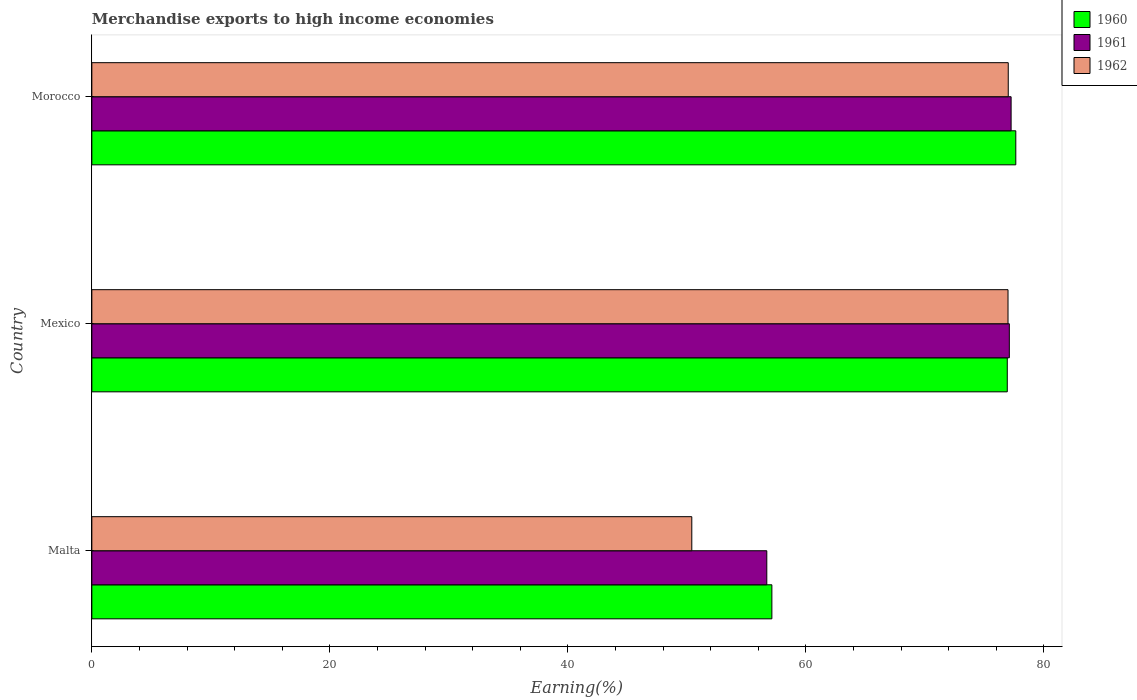How many groups of bars are there?
Ensure brevity in your answer.  3. Are the number of bars per tick equal to the number of legend labels?
Provide a succinct answer. Yes. How many bars are there on the 1st tick from the top?
Make the answer very short. 3. How many bars are there on the 2nd tick from the bottom?
Keep it short and to the point. 3. What is the label of the 1st group of bars from the top?
Ensure brevity in your answer.  Morocco. In how many cases, is the number of bars for a given country not equal to the number of legend labels?
Offer a terse response. 0. What is the percentage of amount earned from merchandise exports in 1960 in Malta?
Keep it short and to the point. 57.14. Across all countries, what is the maximum percentage of amount earned from merchandise exports in 1961?
Your response must be concise. 77.24. Across all countries, what is the minimum percentage of amount earned from merchandise exports in 1960?
Give a very brief answer. 57.14. In which country was the percentage of amount earned from merchandise exports in 1961 maximum?
Provide a short and direct response. Morocco. In which country was the percentage of amount earned from merchandise exports in 1960 minimum?
Keep it short and to the point. Malta. What is the total percentage of amount earned from merchandise exports in 1960 in the graph?
Ensure brevity in your answer.  211.7. What is the difference between the percentage of amount earned from merchandise exports in 1960 in Malta and that in Morocco?
Your answer should be very brief. -20.5. What is the difference between the percentage of amount earned from merchandise exports in 1962 in Morocco and the percentage of amount earned from merchandise exports in 1960 in Malta?
Provide a short and direct response. 19.86. What is the average percentage of amount earned from merchandise exports in 1960 per country?
Keep it short and to the point. 70.57. What is the difference between the percentage of amount earned from merchandise exports in 1962 and percentage of amount earned from merchandise exports in 1960 in Mexico?
Ensure brevity in your answer.  0.06. In how many countries, is the percentage of amount earned from merchandise exports in 1961 greater than 76 %?
Your response must be concise. 2. What is the ratio of the percentage of amount earned from merchandise exports in 1962 in Malta to that in Morocco?
Your answer should be very brief. 0.65. Is the percentage of amount earned from merchandise exports in 1960 in Malta less than that in Morocco?
Your answer should be very brief. Yes. Is the difference between the percentage of amount earned from merchandise exports in 1962 in Malta and Morocco greater than the difference between the percentage of amount earned from merchandise exports in 1960 in Malta and Morocco?
Ensure brevity in your answer.  No. What is the difference between the highest and the second highest percentage of amount earned from merchandise exports in 1961?
Make the answer very short. 0.15. What is the difference between the highest and the lowest percentage of amount earned from merchandise exports in 1960?
Provide a short and direct response. 20.5. What does the 1st bar from the bottom in Malta represents?
Ensure brevity in your answer.  1960. Are all the bars in the graph horizontal?
Ensure brevity in your answer.  Yes. How many countries are there in the graph?
Offer a terse response. 3. Does the graph contain grids?
Give a very brief answer. No. Where does the legend appear in the graph?
Keep it short and to the point. Top right. How are the legend labels stacked?
Keep it short and to the point. Vertical. What is the title of the graph?
Make the answer very short. Merchandise exports to high income economies. What is the label or title of the X-axis?
Offer a very short reply. Earning(%). What is the label or title of the Y-axis?
Provide a succinct answer. Country. What is the Earning(%) in 1960 in Malta?
Ensure brevity in your answer.  57.14. What is the Earning(%) in 1961 in Malta?
Offer a very short reply. 56.72. What is the Earning(%) of 1962 in Malta?
Offer a terse response. 50.41. What is the Earning(%) of 1960 in Mexico?
Offer a terse response. 76.92. What is the Earning(%) in 1961 in Mexico?
Provide a succinct answer. 77.1. What is the Earning(%) of 1962 in Mexico?
Make the answer very short. 76.99. What is the Earning(%) in 1960 in Morocco?
Give a very brief answer. 77.64. What is the Earning(%) of 1961 in Morocco?
Ensure brevity in your answer.  77.24. What is the Earning(%) in 1962 in Morocco?
Offer a very short reply. 77.01. Across all countries, what is the maximum Earning(%) of 1960?
Ensure brevity in your answer.  77.64. Across all countries, what is the maximum Earning(%) of 1961?
Your answer should be compact. 77.24. Across all countries, what is the maximum Earning(%) in 1962?
Offer a terse response. 77.01. Across all countries, what is the minimum Earning(%) of 1960?
Ensure brevity in your answer.  57.14. Across all countries, what is the minimum Earning(%) in 1961?
Your response must be concise. 56.72. Across all countries, what is the minimum Earning(%) in 1962?
Keep it short and to the point. 50.41. What is the total Earning(%) of 1960 in the graph?
Offer a terse response. 211.71. What is the total Earning(%) in 1961 in the graph?
Ensure brevity in your answer.  211.06. What is the total Earning(%) of 1962 in the graph?
Offer a very short reply. 204.4. What is the difference between the Earning(%) of 1960 in Malta and that in Mexico?
Ensure brevity in your answer.  -19.78. What is the difference between the Earning(%) of 1961 in Malta and that in Mexico?
Your answer should be compact. -20.38. What is the difference between the Earning(%) in 1962 in Malta and that in Mexico?
Give a very brief answer. -26.57. What is the difference between the Earning(%) in 1960 in Malta and that in Morocco?
Provide a succinct answer. -20.5. What is the difference between the Earning(%) of 1961 in Malta and that in Morocco?
Offer a very short reply. -20.53. What is the difference between the Earning(%) of 1962 in Malta and that in Morocco?
Provide a short and direct response. -26.59. What is the difference between the Earning(%) of 1960 in Mexico and that in Morocco?
Provide a short and direct response. -0.72. What is the difference between the Earning(%) in 1961 in Mexico and that in Morocco?
Your answer should be very brief. -0.15. What is the difference between the Earning(%) of 1962 in Mexico and that in Morocco?
Make the answer very short. -0.02. What is the difference between the Earning(%) in 1960 in Malta and the Earning(%) in 1961 in Mexico?
Give a very brief answer. -19.95. What is the difference between the Earning(%) of 1960 in Malta and the Earning(%) of 1962 in Mexico?
Your answer should be compact. -19.84. What is the difference between the Earning(%) of 1961 in Malta and the Earning(%) of 1962 in Mexico?
Your answer should be compact. -20.27. What is the difference between the Earning(%) of 1960 in Malta and the Earning(%) of 1961 in Morocco?
Keep it short and to the point. -20.1. What is the difference between the Earning(%) of 1960 in Malta and the Earning(%) of 1962 in Morocco?
Your answer should be very brief. -19.86. What is the difference between the Earning(%) in 1961 in Malta and the Earning(%) in 1962 in Morocco?
Your answer should be compact. -20.29. What is the difference between the Earning(%) in 1960 in Mexico and the Earning(%) in 1961 in Morocco?
Provide a succinct answer. -0.32. What is the difference between the Earning(%) in 1960 in Mexico and the Earning(%) in 1962 in Morocco?
Give a very brief answer. -0.08. What is the difference between the Earning(%) of 1961 in Mexico and the Earning(%) of 1962 in Morocco?
Give a very brief answer. 0.09. What is the average Earning(%) of 1960 per country?
Your answer should be compact. 70.57. What is the average Earning(%) in 1961 per country?
Offer a terse response. 70.35. What is the average Earning(%) in 1962 per country?
Your response must be concise. 68.13. What is the difference between the Earning(%) of 1960 and Earning(%) of 1961 in Malta?
Give a very brief answer. 0.43. What is the difference between the Earning(%) of 1960 and Earning(%) of 1962 in Malta?
Make the answer very short. 6.73. What is the difference between the Earning(%) in 1961 and Earning(%) in 1962 in Malta?
Give a very brief answer. 6.3. What is the difference between the Earning(%) of 1960 and Earning(%) of 1961 in Mexico?
Give a very brief answer. -0.17. What is the difference between the Earning(%) in 1960 and Earning(%) in 1962 in Mexico?
Your answer should be very brief. -0.06. What is the difference between the Earning(%) of 1961 and Earning(%) of 1962 in Mexico?
Offer a very short reply. 0.11. What is the difference between the Earning(%) of 1960 and Earning(%) of 1961 in Morocco?
Offer a terse response. 0.39. What is the difference between the Earning(%) of 1960 and Earning(%) of 1962 in Morocco?
Your response must be concise. 0.63. What is the difference between the Earning(%) of 1961 and Earning(%) of 1962 in Morocco?
Your answer should be compact. 0.24. What is the ratio of the Earning(%) in 1960 in Malta to that in Mexico?
Ensure brevity in your answer.  0.74. What is the ratio of the Earning(%) of 1961 in Malta to that in Mexico?
Provide a succinct answer. 0.74. What is the ratio of the Earning(%) in 1962 in Malta to that in Mexico?
Your answer should be very brief. 0.65. What is the ratio of the Earning(%) of 1960 in Malta to that in Morocco?
Your answer should be very brief. 0.74. What is the ratio of the Earning(%) in 1961 in Malta to that in Morocco?
Ensure brevity in your answer.  0.73. What is the ratio of the Earning(%) in 1962 in Malta to that in Morocco?
Your answer should be compact. 0.65. What is the ratio of the Earning(%) of 1961 in Mexico to that in Morocco?
Provide a succinct answer. 1. What is the difference between the highest and the second highest Earning(%) of 1960?
Your answer should be compact. 0.72. What is the difference between the highest and the second highest Earning(%) in 1961?
Keep it short and to the point. 0.15. What is the difference between the highest and the second highest Earning(%) in 1962?
Keep it short and to the point. 0.02. What is the difference between the highest and the lowest Earning(%) of 1960?
Give a very brief answer. 20.5. What is the difference between the highest and the lowest Earning(%) of 1961?
Your answer should be compact. 20.53. What is the difference between the highest and the lowest Earning(%) in 1962?
Make the answer very short. 26.59. 